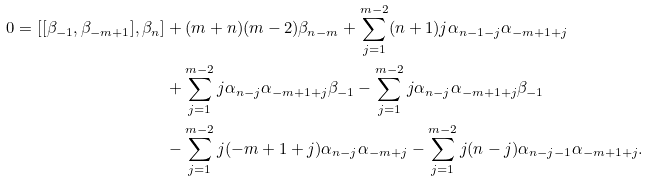Convert formula to latex. <formula><loc_0><loc_0><loc_500><loc_500>0 = [ [ \beta _ { - 1 } , \beta _ { - m + 1 } ] , \beta _ { n } ] & + ( m + n ) ( m - 2 ) \beta _ { n - m } + \sum _ { j = 1 } ^ { m - 2 } ( n + 1 ) j \alpha _ { n - 1 - j } \alpha _ { - m + 1 + j } \\ & + \sum _ { j = 1 } ^ { m - 2 } j \alpha _ { n - j } \alpha _ { - m + 1 + j } \beta _ { - 1 } - \sum _ { j = 1 } ^ { m - 2 } j \alpha _ { n - j } \alpha _ { - m + 1 + j } \beta _ { - 1 } \\ & - \sum _ { j = 1 } ^ { m - 2 } j ( - m + 1 + j ) \alpha _ { n - j } \alpha _ { - m + j } - \sum _ { j = 1 } ^ { m - 2 } j ( n - j ) \alpha _ { n - j - 1 } \alpha _ { - m + 1 + j } .</formula> 